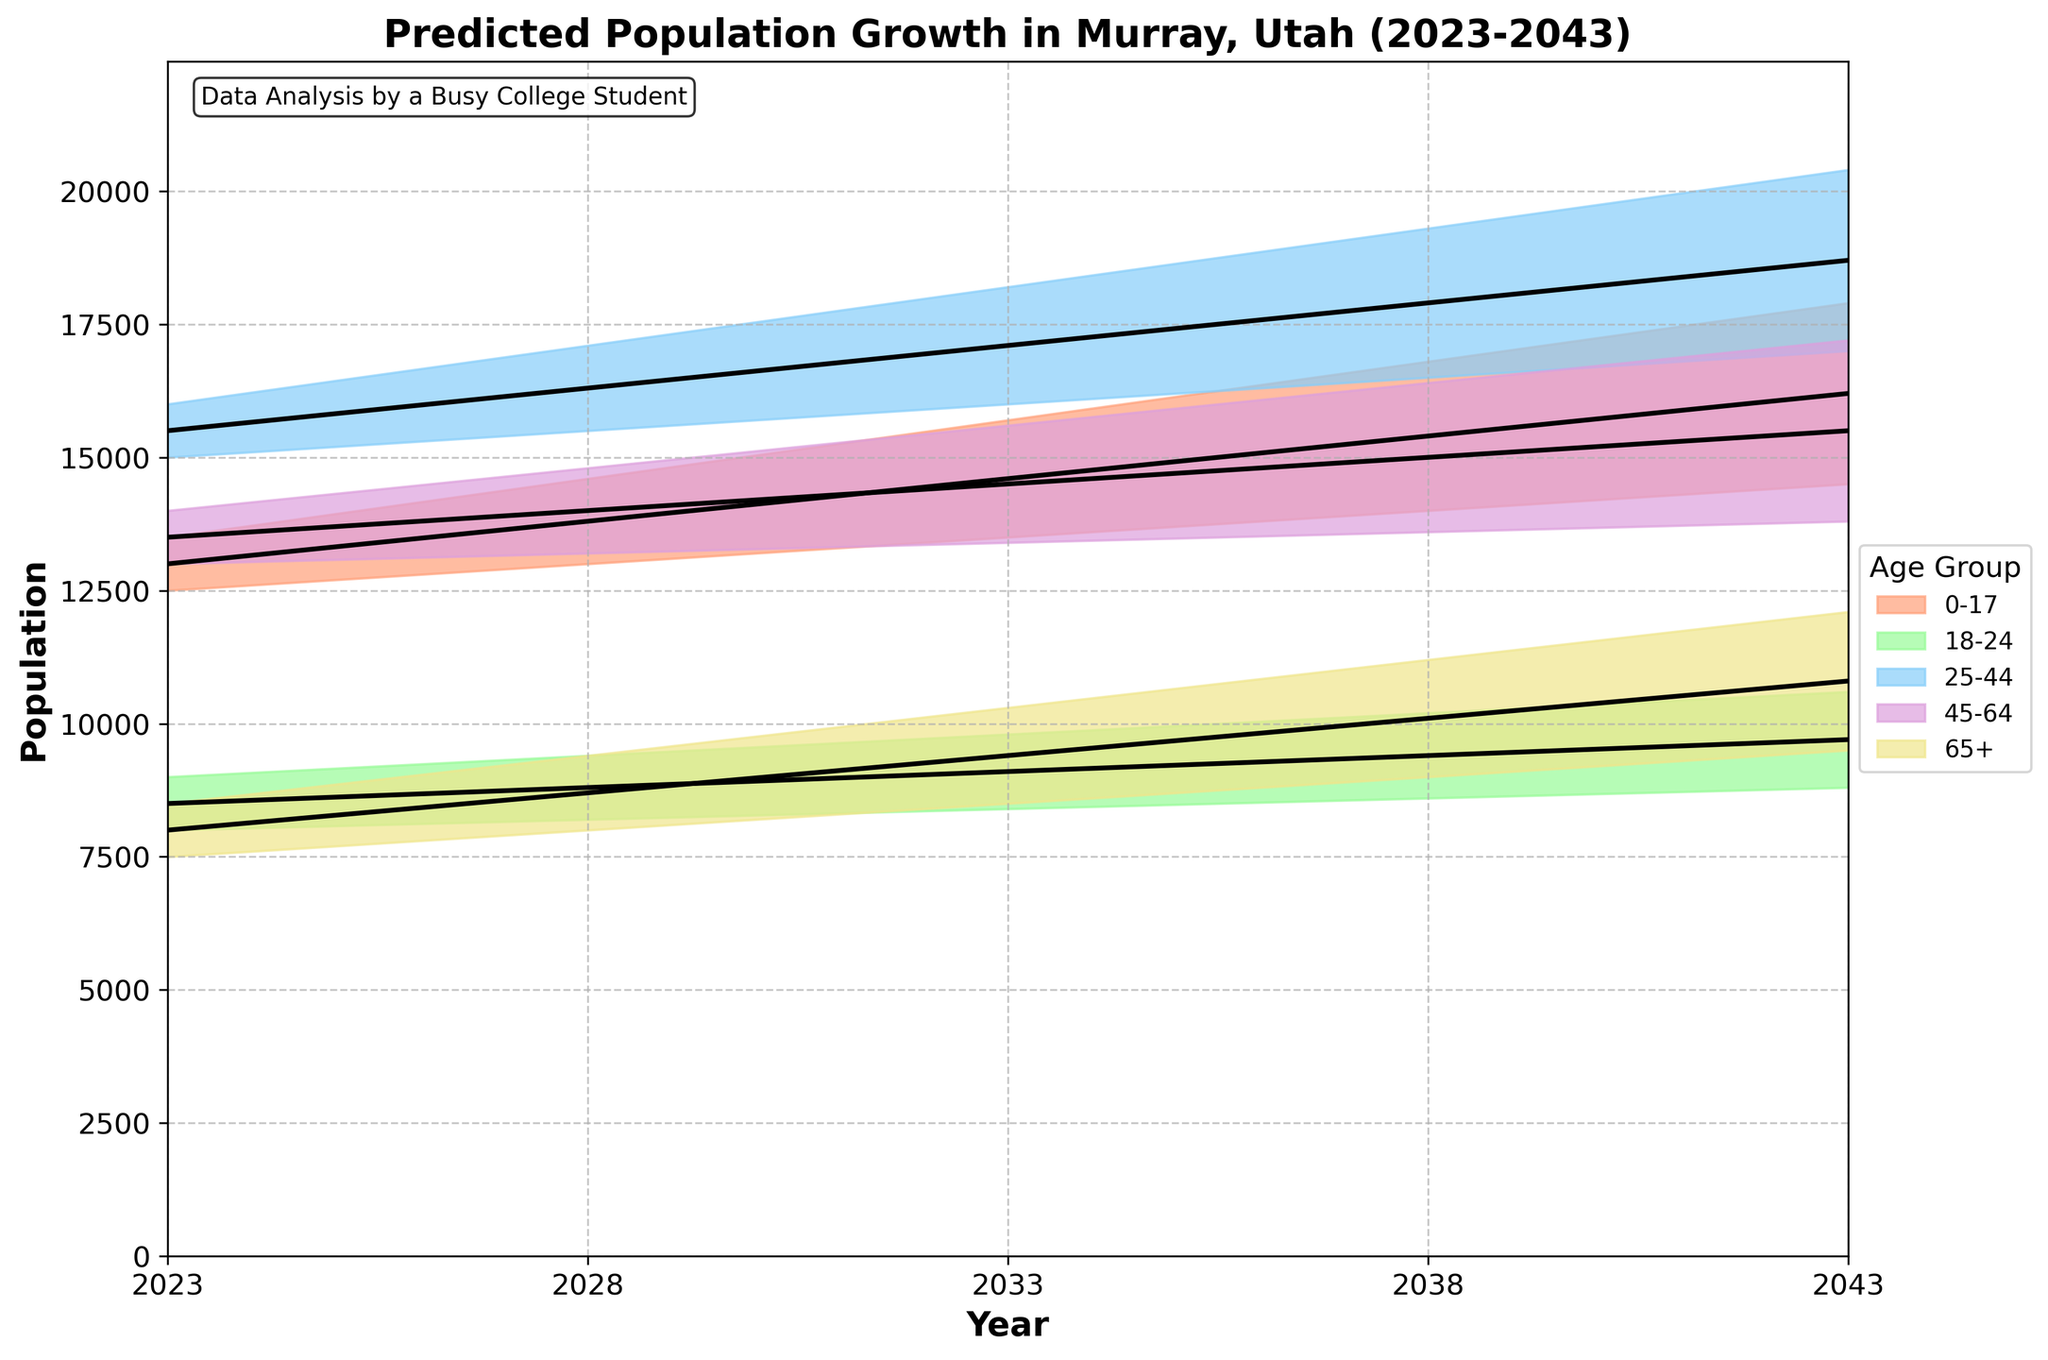What is the title of the figure? The title is typically located at the top of the figure. You can directly read it from there.
Answer: Predicted Population Growth in Murray, Utah (2023-2043) What years are shown in the figure? To find the years, look along the x-axis which represents time. The distinct points will tell you the years included.
Answer: 2023, 2028, 2033, 2038, 2043 Which age group has the highest medium estimate in 2043? Look at the lines marked with black for the year 2043 for each age group. The one with the highest value indicates the group with the highest medium estimate.
Answer: 25-44 How does the population estimate for the age group 18-24 change from 2023 to 2043 under the medium scenario? Identify the points on the black line for the 18-24 age group at the years 2023 and 2043, and note the change in their values.
Answer: It increases from 8500 to 9700 What is the population range for the age group 65+ in 2038? Look at the shaded area for the age group 65+ at the year 2038 to find the lower and upper limits.
Answer: 9000 to 11200 Compare the highest low estimate for any age group in 2028 to the lowest high estimate for any age group in 2043. Identify the highest low estimate for any age group in 2028 and the lowest high estimate for any age group in 2043 and compare them.
Answer: 15500 (2028, 25-44) vs. 10600 (2043, 18-24) What can you infer if the actual population growth matches the high estimates for all age groups? If actual population matches high estimates, read the upper boundaries of the shaded areas for each age group over the years, summing them up to understand the trends and projections for the total population in the future.
Answer: Significant population increase across all age groups Which age group is projected to have the smallest percentage change in their medium estimate from 2023 to 2043? Calculate the percentage change ((2043 value - 2023 value) / 2023 value * 100) for the medium estimates of all age groups. The group with the smallest percentage change is the answer.
Answer: 45-64 What age group is expected to have the most significant increase in population by 2043 under the high estimate scenario? Compare the high estimates (top edge of the shaded area) for 2043 to the corresponding values for 2023 and find the age group with the most significant absolute change.
Answer: 25-44 How does the trend in population growth for the age group 0-17 compare to that of 65+ over the projected period? Observe the slopes from 2023 to 2043 for both age groups in their respective shaded areas and medium estimate lines. Compare their trends by looking at the relative steepness and direction (upward/downward) of the lines.
Answer: Both increase, but 0-17 grows at a slightly lower rate 